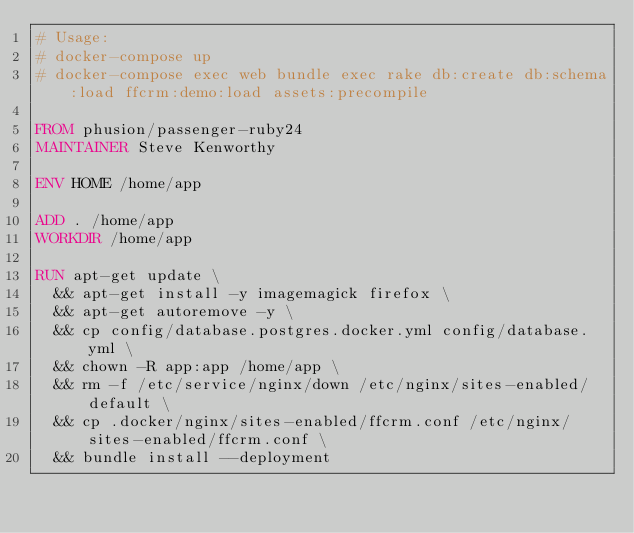Convert code to text. <code><loc_0><loc_0><loc_500><loc_500><_Dockerfile_># Usage:
# docker-compose up
# docker-compose exec web bundle exec rake db:create db:schema:load ffcrm:demo:load assets:precompile

FROM phusion/passenger-ruby24
MAINTAINER Steve Kenworthy

ENV HOME /home/app

ADD . /home/app
WORKDIR /home/app

RUN apt-get update \
  && apt-get install -y imagemagick firefox \
  && apt-get autoremove -y \
  && cp config/database.postgres.docker.yml config/database.yml \
  && chown -R app:app /home/app \
  && rm -f /etc/service/nginx/down /etc/nginx/sites-enabled/default \
  && cp .docker/nginx/sites-enabled/ffcrm.conf /etc/nginx/sites-enabled/ffcrm.conf \
  && bundle install --deployment
</code> 